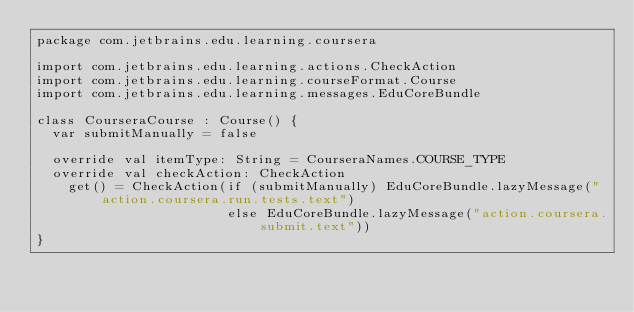Convert code to text. <code><loc_0><loc_0><loc_500><loc_500><_Kotlin_>package com.jetbrains.edu.learning.coursera

import com.jetbrains.edu.learning.actions.CheckAction
import com.jetbrains.edu.learning.courseFormat.Course
import com.jetbrains.edu.learning.messages.EduCoreBundle

class CourseraCourse : Course() {
  var submitManually = false

  override val itemType: String = CourseraNames.COURSE_TYPE
  override val checkAction: CheckAction
    get() = CheckAction(if (submitManually) EduCoreBundle.lazyMessage("action.coursera.run.tests.text")
                        else EduCoreBundle.lazyMessage("action.coursera.submit.text"))
}
</code> 